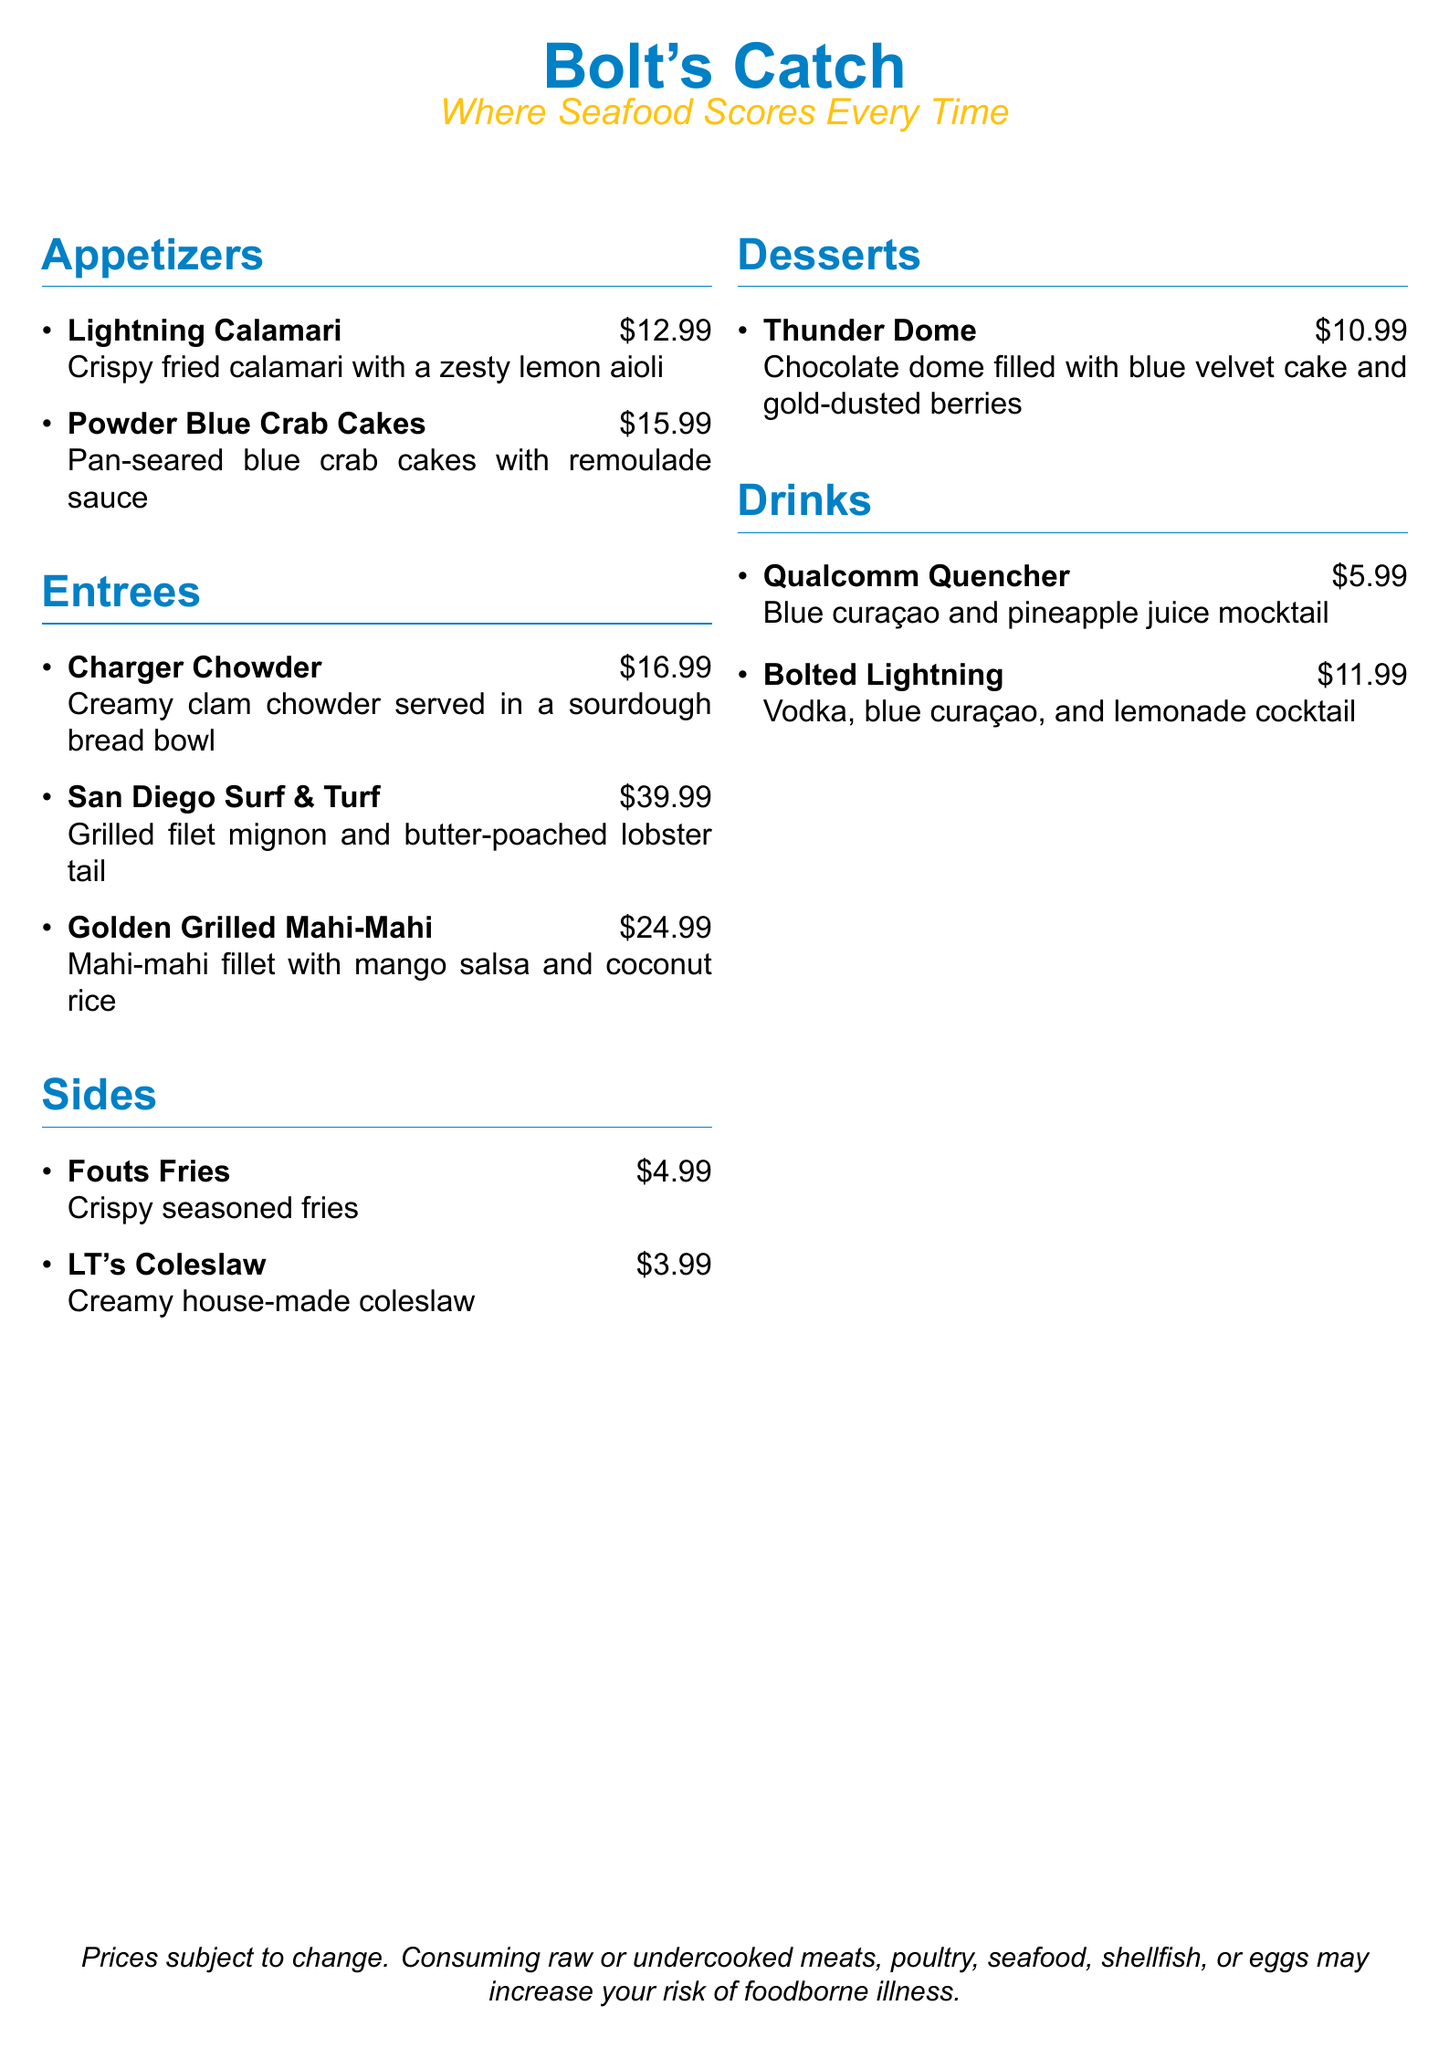what is the name of the restaurant? The restaurant's name is prominently displayed at the top of the menu.
Answer: Bolt's Catch how much do the Powder Blue Crab Cakes cost? The menu lists the price of Powder Blue Crab Cakes in the appetizers section.
Answer: $15.99 what is the main ingredient in Charger Chowder? The description of Charger Chowder mentions the specific type of seafood used.
Answer: Clams what drink contains blue curaçao? The drinks section provides names that include blue curaçao as an ingredient.
Answer: Qualcomm Quencher how many sides are listed on the menu? The menu shows the number of side dishes available in the sides section.
Answer: 2 which dessert features blue velvet cake? The dessert section states the contents of the Thunder Dome dessert.
Answer: Thunder Dome what is the price of San Diego Surf & Turf? The menu includes the price for San Diego Surf & Turf in the entrees section.
Answer: $39.99 what color scheme is used in the restaurant menu? The colors in the menu's design are described in the context of the chosen theme.
Answer: Blue and Gold which appetizer has a zesty lemon aioli? The menu describes the Lightning Calamari as having a specific sauce.
Answer: Lightning Calamari 